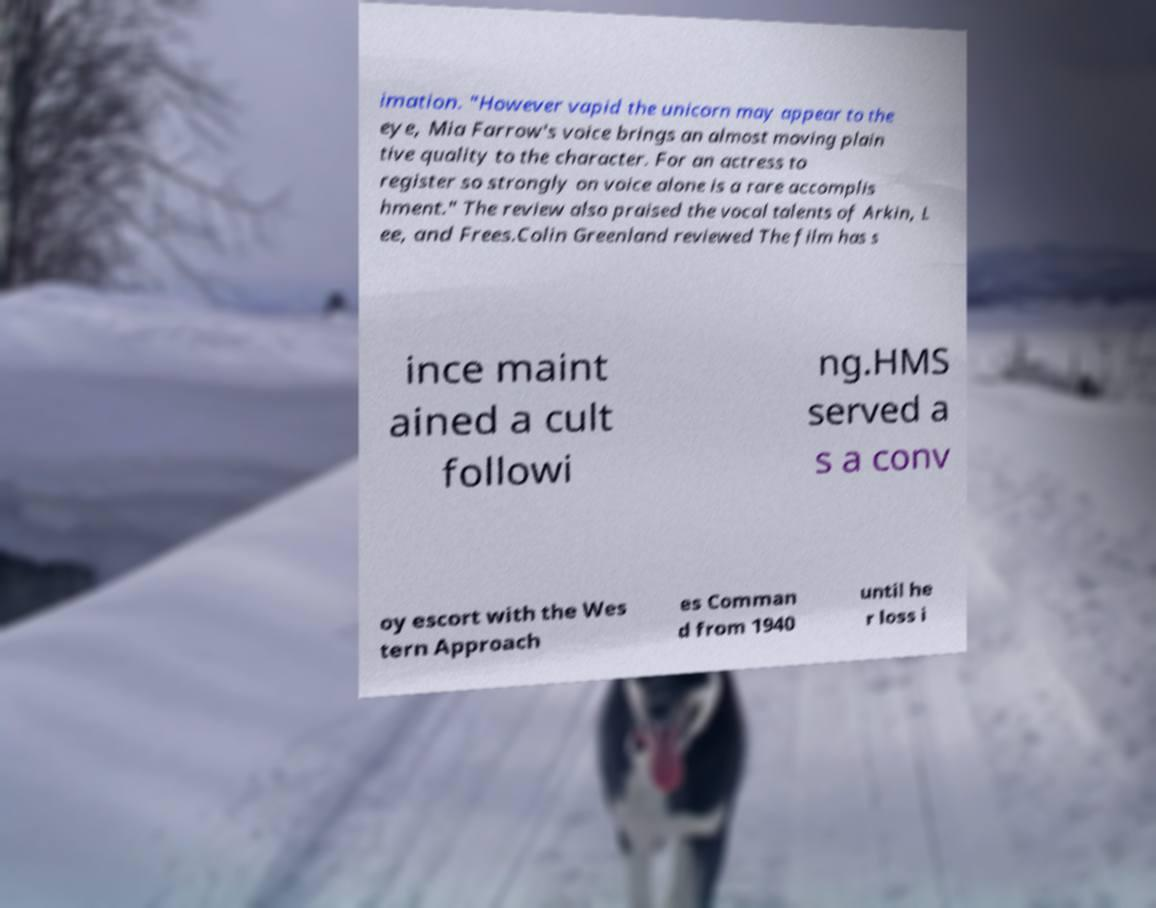I need the written content from this picture converted into text. Can you do that? imation. "However vapid the unicorn may appear to the eye, Mia Farrow's voice brings an almost moving plain tive quality to the character. For an actress to register so strongly on voice alone is a rare accomplis hment." The review also praised the vocal talents of Arkin, L ee, and Frees.Colin Greenland reviewed The film has s ince maint ained a cult followi ng.HMS served a s a conv oy escort with the Wes tern Approach es Comman d from 1940 until he r loss i 